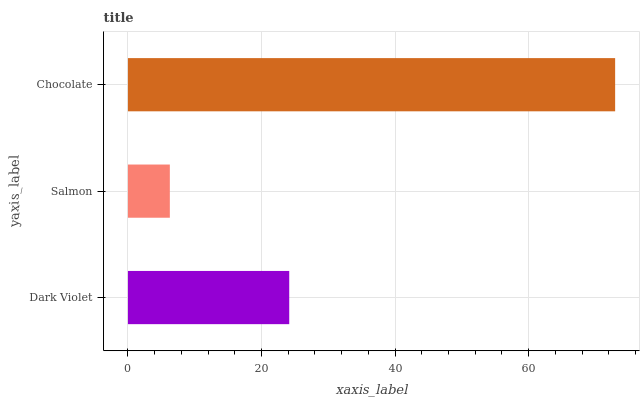Is Salmon the minimum?
Answer yes or no. Yes. Is Chocolate the maximum?
Answer yes or no. Yes. Is Chocolate the minimum?
Answer yes or no. No. Is Salmon the maximum?
Answer yes or no. No. Is Chocolate greater than Salmon?
Answer yes or no. Yes. Is Salmon less than Chocolate?
Answer yes or no. Yes. Is Salmon greater than Chocolate?
Answer yes or no. No. Is Chocolate less than Salmon?
Answer yes or no. No. Is Dark Violet the high median?
Answer yes or no. Yes. Is Dark Violet the low median?
Answer yes or no. Yes. Is Salmon the high median?
Answer yes or no. No. Is Chocolate the low median?
Answer yes or no. No. 